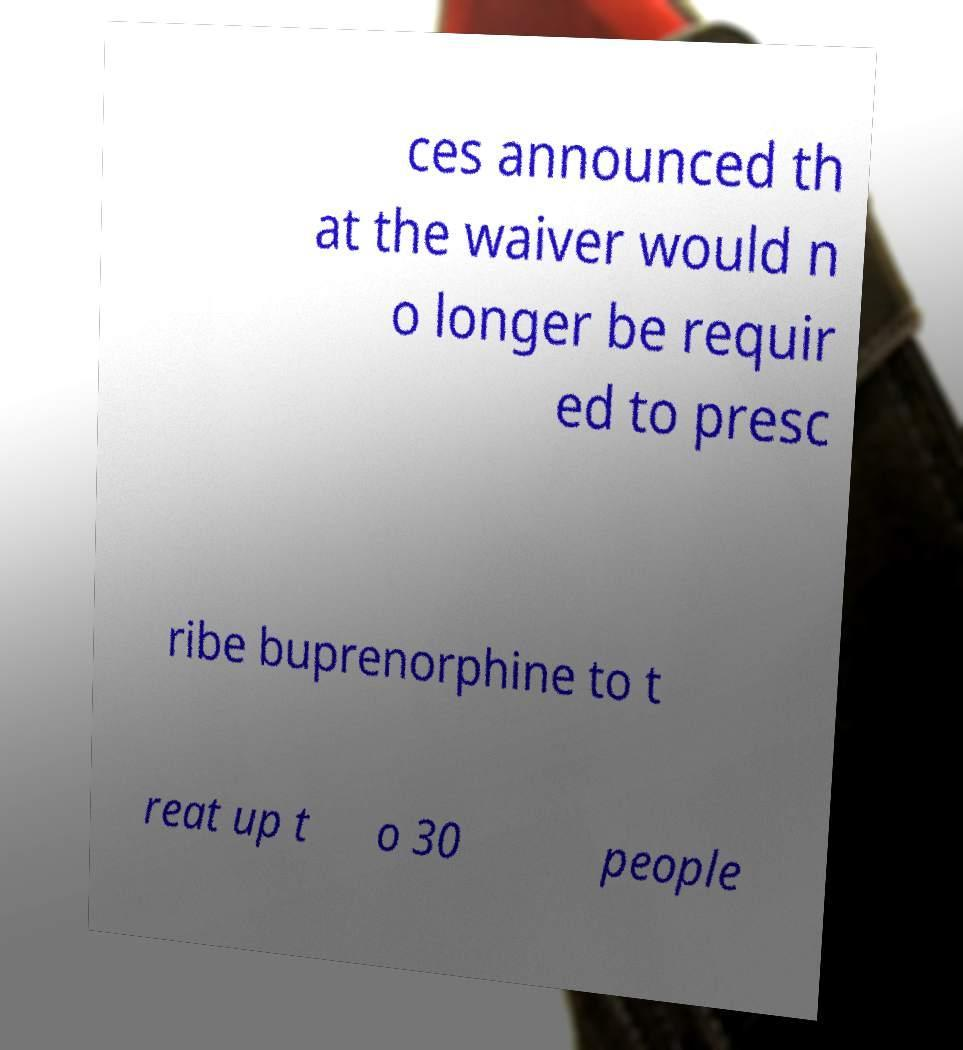For documentation purposes, I need the text within this image transcribed. Could you provide that? ces announced th at the waiver would n o longer be requir ed to presc ribe buprenorphine to t reat up t o 30 people 